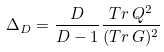Convert formula to latex. <formula><loc_0><loc_0><loc_500><loc_500>\Delta _ { D } = \frac { D } { D - 1 } \frac { T r \, Q ^ { 2 } } { ( T r \, G ) ^ { 2 } }</formula> 